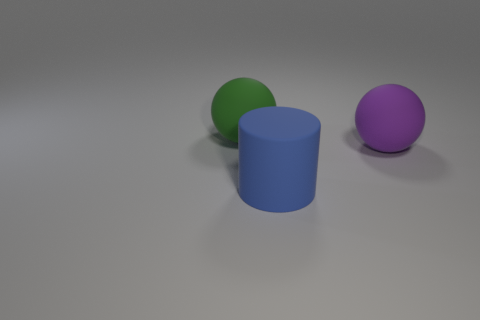Subtract 1 cylinders. How many cylinders are left? 0 Subtract all green spheres. Subtract all red cylinders. How many spheres are left? 1 Subtract all cyan balls. How many brown cylinders are left? 0 Subtract all big blue cylinders. Subtract all big cylinders. How many objects are left? 1 Add 2 big blue things. How many big blue things are left? 3 Add 3 big spheres. How many big spheres exist? 5 Add 2 blue objects. How many objects exist? 5 Subtract 0 gray balls. How many objects are left? 3 Subtract all spheres. How many objects are left? 1 